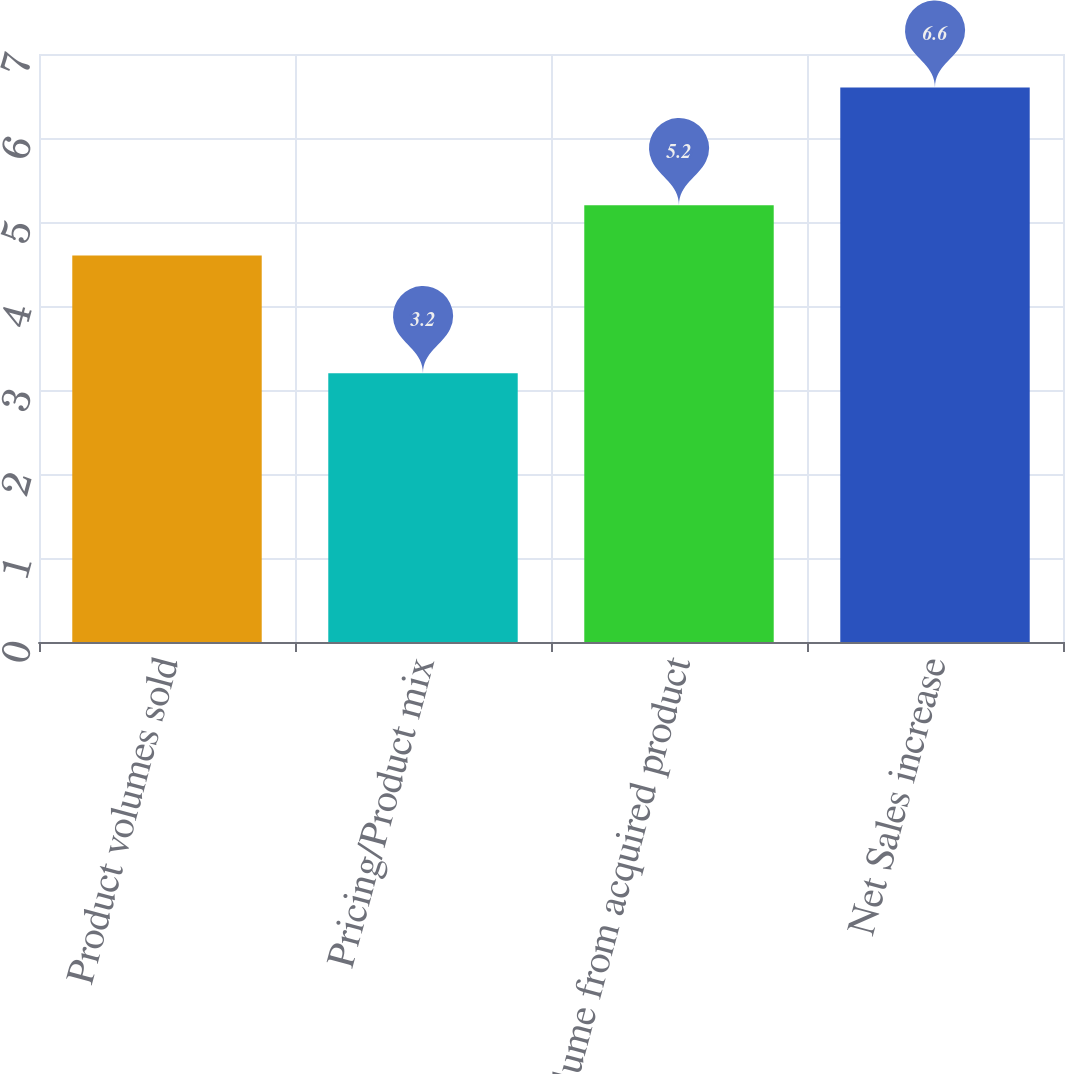Convert chart to OTSL. <chart><loc_0><loc_0><loc_500><loc_500><bar_chart><fcel>Product volumes sold<fcel>Pricing/Product mix<fcel>Volume from acquired product<fcel>Net Sales increase<nl><fcel>4.6<fcel>3.2<fcel>5.2<fcel>6.6<nl></chart> 